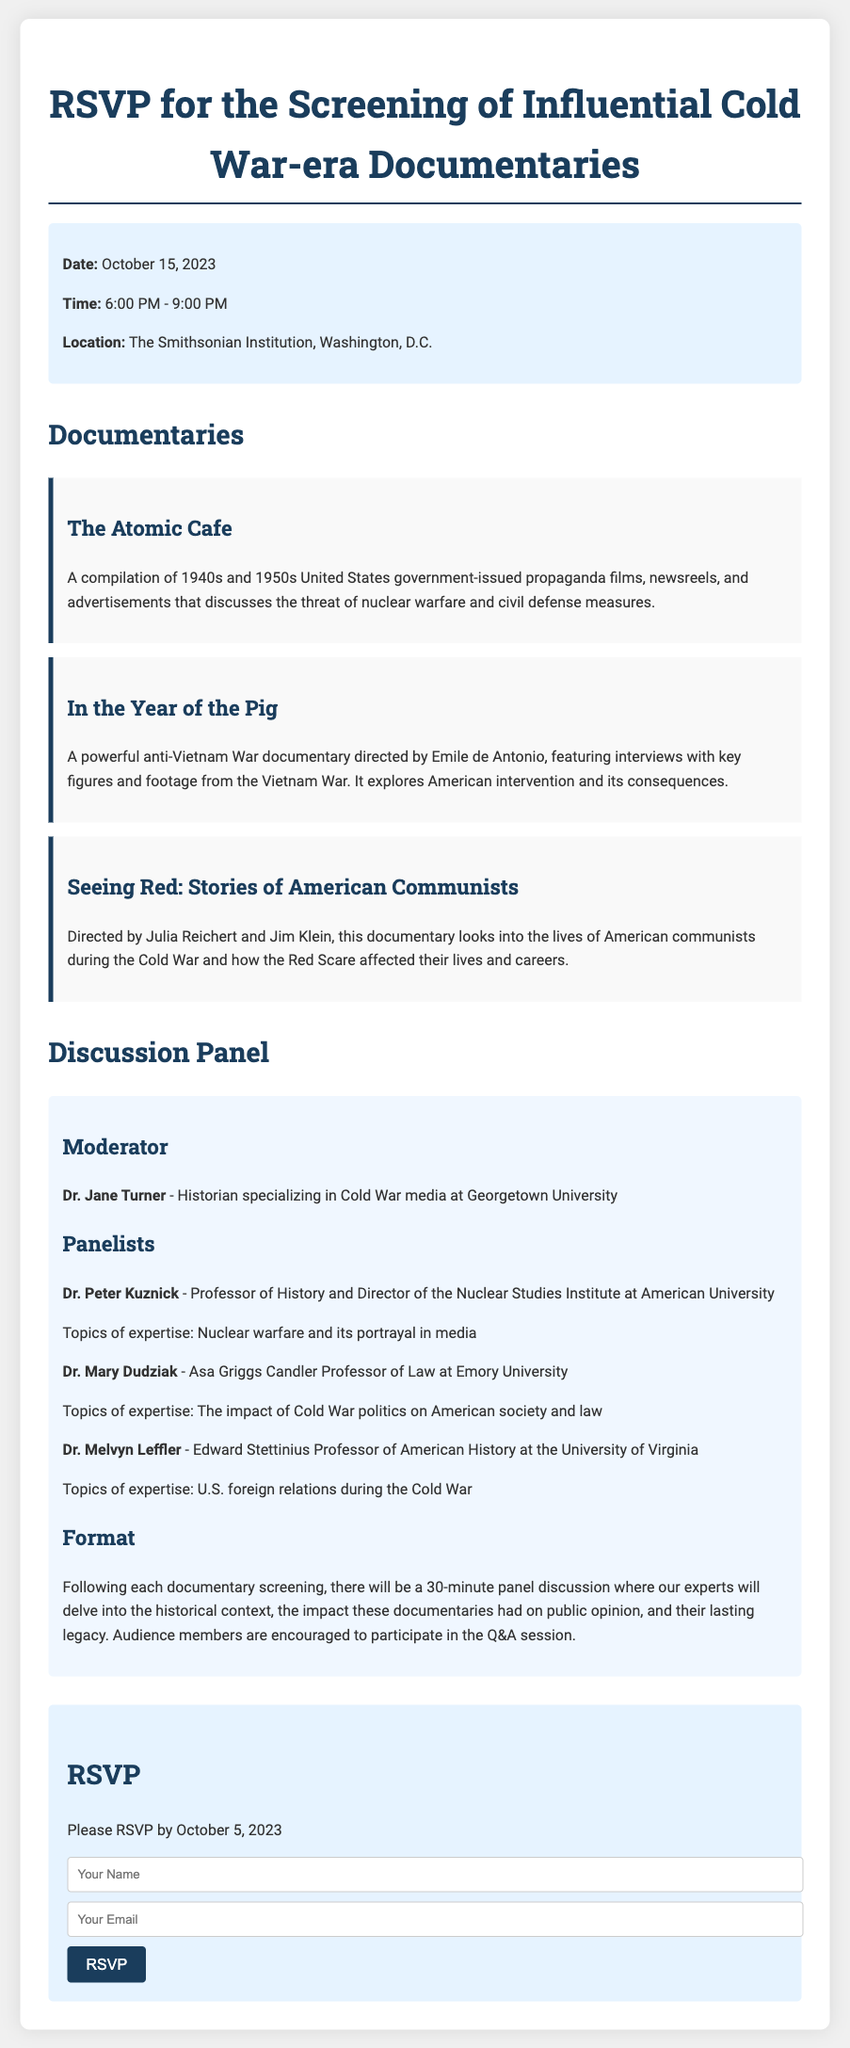What is the date of the screening? The date of the screening is mentioned clearly in the event details section of the RSVP card.
Answer: October 15, 2023 What time does the event start? The event's starting time is provided in the event details section.
Answer: 6:00 PM Where is the screening taking place? The location of the screening is specified in the event details section.
Answer: The Smithsonian Institution, Washington, D.C Who is the moderator for the discussion panel? The moderator's name and title are included in the discussion panel section.
Answer: Dr. Jane Turner Which documentary discusses nuclear warfare and civil defense measures? The description of the documentaries provides information about their themes.
Answer: The Atomic Cafe How many panelists are listed in the discussion section? The number of panelists can be counted from the list provided in the panel section.
Answer: Three What is the deadline for RSVPing? The RSVP deadline is explicitly stated in the RSVP section of the document.
Answer: October 5, 2023 What is the format of the panel discussion after each documentary? The format for the panel discussion is described in the discussion panel section.
Answer: 30-minute panel discussion 